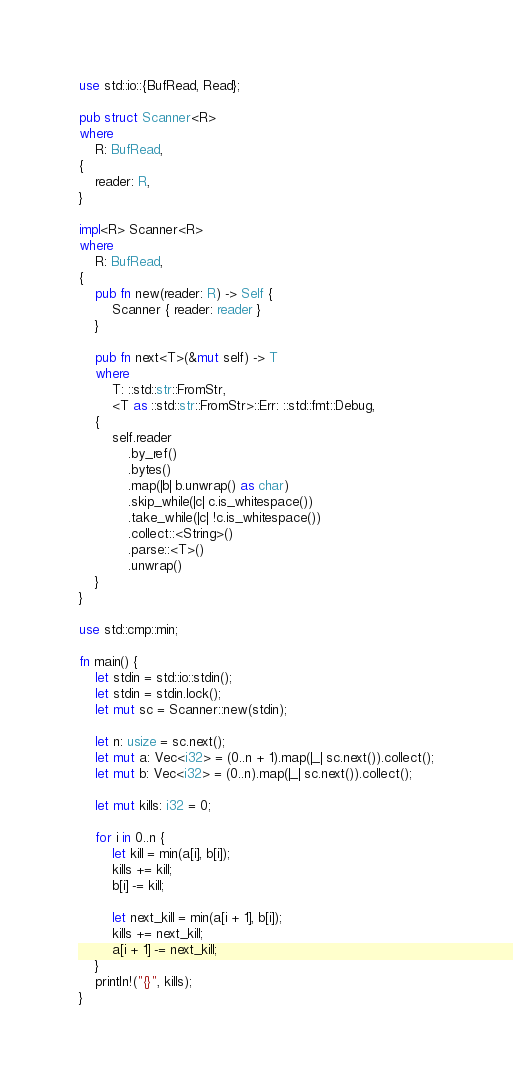Convert code to text. <code><loc_0><loc_0><loc_500><loc_500><_Rust_>use std::io::{BufRead, Read};

pub struct Scanner<R>
where
    R: BufRead,
{
    reader: R,
}

impl<R> Scanner<R>
where
    R: BufRead,
{
    pub fn new(reader: R) -> Self {
        Scanner { reader: reader }
    }

    pub fn next<T>(&mut self) -> T
    where
        T: ::std::str::FromStr,
        <T as ::std::str::FromStr>::Err: ::std::fmt::Debug,
    {
        self.reader
            .by_ref()
            .bytes()
            .map(|b| b.unwrap() as char)
            .skip_while(|c| c.is_whitespace())
            .take_while(|c| !c.is_whitespace())
            .collect::<String>()
            .parse::<T>()
            .unwrap()
    }
}

use std::cmp::min;

fn main() {
    let stdin = std::io::stdin();
    let stdin = stdin.lock();
    let mut sc = Scanner::new(stdin);

    let n: usize = sc.next();
    let mut a: Vec<i32> = (0..n + 1).map(|_| sc.next()).collect();
    let mut b: Vec<i32> = (0..n).map(|_| sc.next()).collect();

    let mut kills: i32 = 0;

    for i in 0..n {
        let kill = min(a[i], b[i]);
        kills += kill;
        b[i] -= kill;

        let next_kill = min(a[i + 1], b[i]);
        kills += next_kill;
        a[i + 1] -= next_kill;
    }
    println!("{}", kills);
}
</code> 